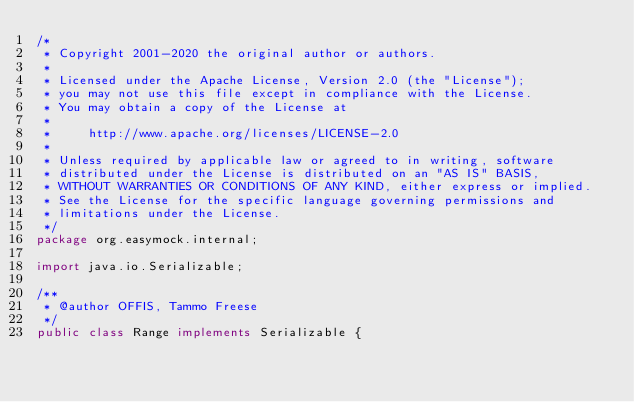<code> <loc_0><loc_0><loc_500><loc_500><_Java_>/*
 * Copyright 2001-2020 the original author or authors.
 *
 * Licensed under the Apache License, Version 2.0 (the "License");
 * you may not use this file except in compliance with the License.
 * You may obtain a copy of the License at
 *
 *     http://www.apache.org/licenses/LICENSE-2.0
 *
 * Unless required by applicable law or agreed to in writing, software
 * distributed under the License is distributed on an "AS IS" BASIS,
 * WITHOUT WARRANTIES OR CONDITIONS OF ANY KIND, either express or implied.
 * See the License for the specific language governing permissions and
 * limitations under the License.
 */
package org.easymock.internal;

import java.io.Serializable;

/**
 * @author OFFIS, Tammo Freese
 */
public class Range implements Serializable {
</code> 